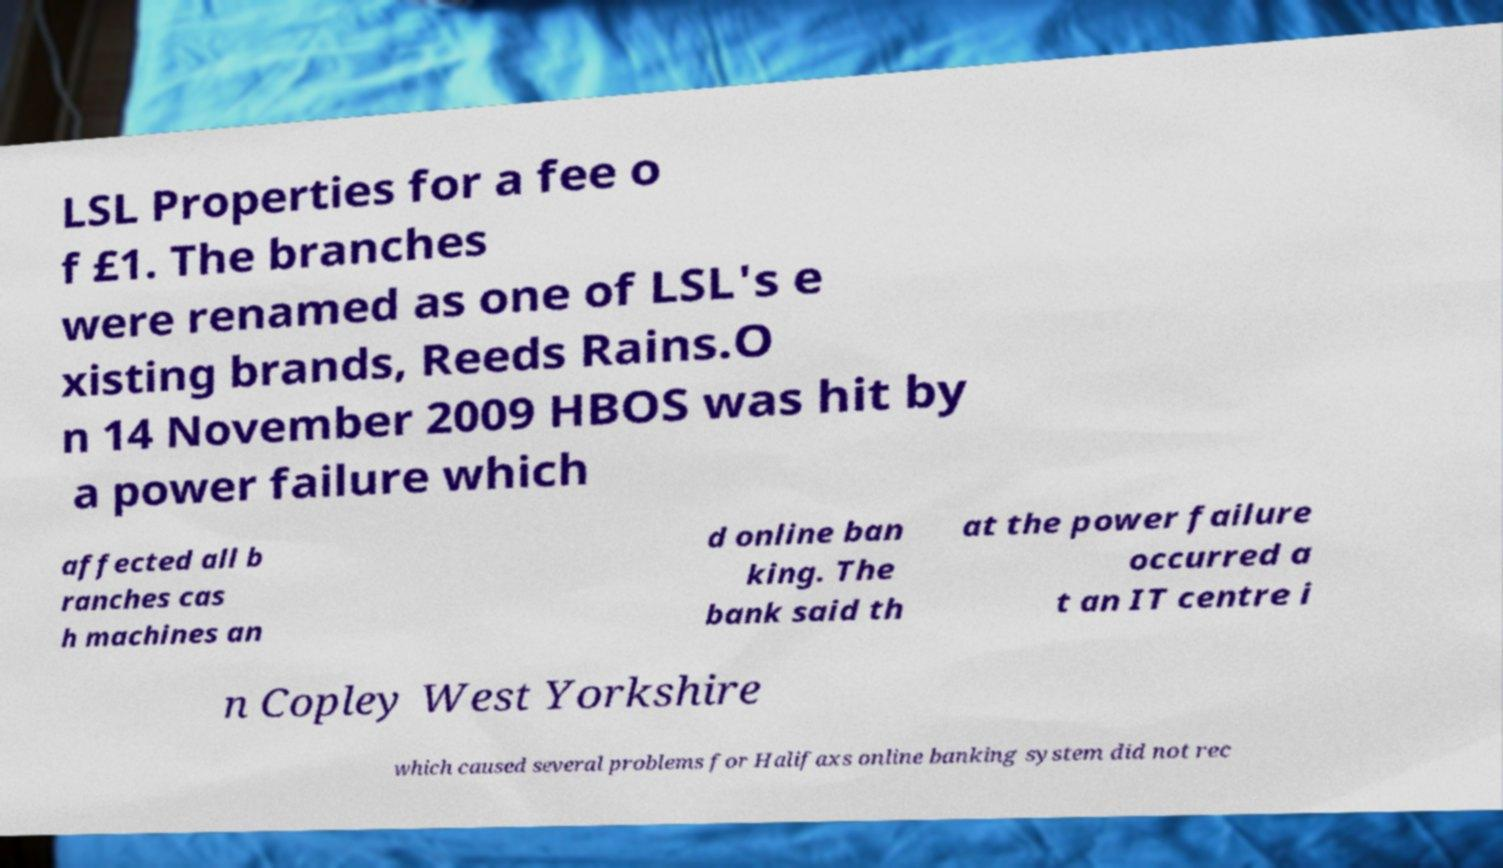Can you accurately transcribe the text from the provided image for me? LSL Properties for a fee o f £1. The branches were renamed as one of LSL's e xisting brands, Reeds Rains.O n 14 November 2009 HBOS was hit by a power failure which affected all b ranches cas h machines an d online ban king. The bank said th at the power failure occurred a t an IT centre i n Copley West Yorkshire which caused several problems for Halifaxs online banking system did not rec 